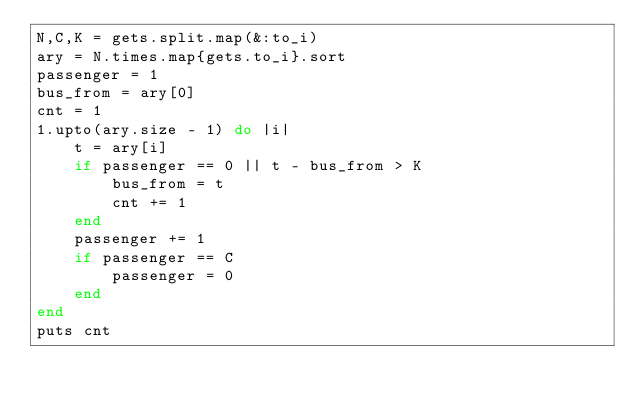<code> <loc_0><loc_0><loc_500><loc_500><_Ruby_>N,C,K = gets.split.map(&:to_i)
ary = N.times.map{gets.to_i}.sort
passenger = 1
bus_from = ary[0]
cnt = 1
1.upto(ary.size - 1) do |i|
    t = ary[i]
    if passenger == 0 || t - bus_from > K
        bus_from = t
        cnt += 1
    end
    passenger += 1
    if passenger == C
        passenger = 0
    end
end
puts cnt</code> 